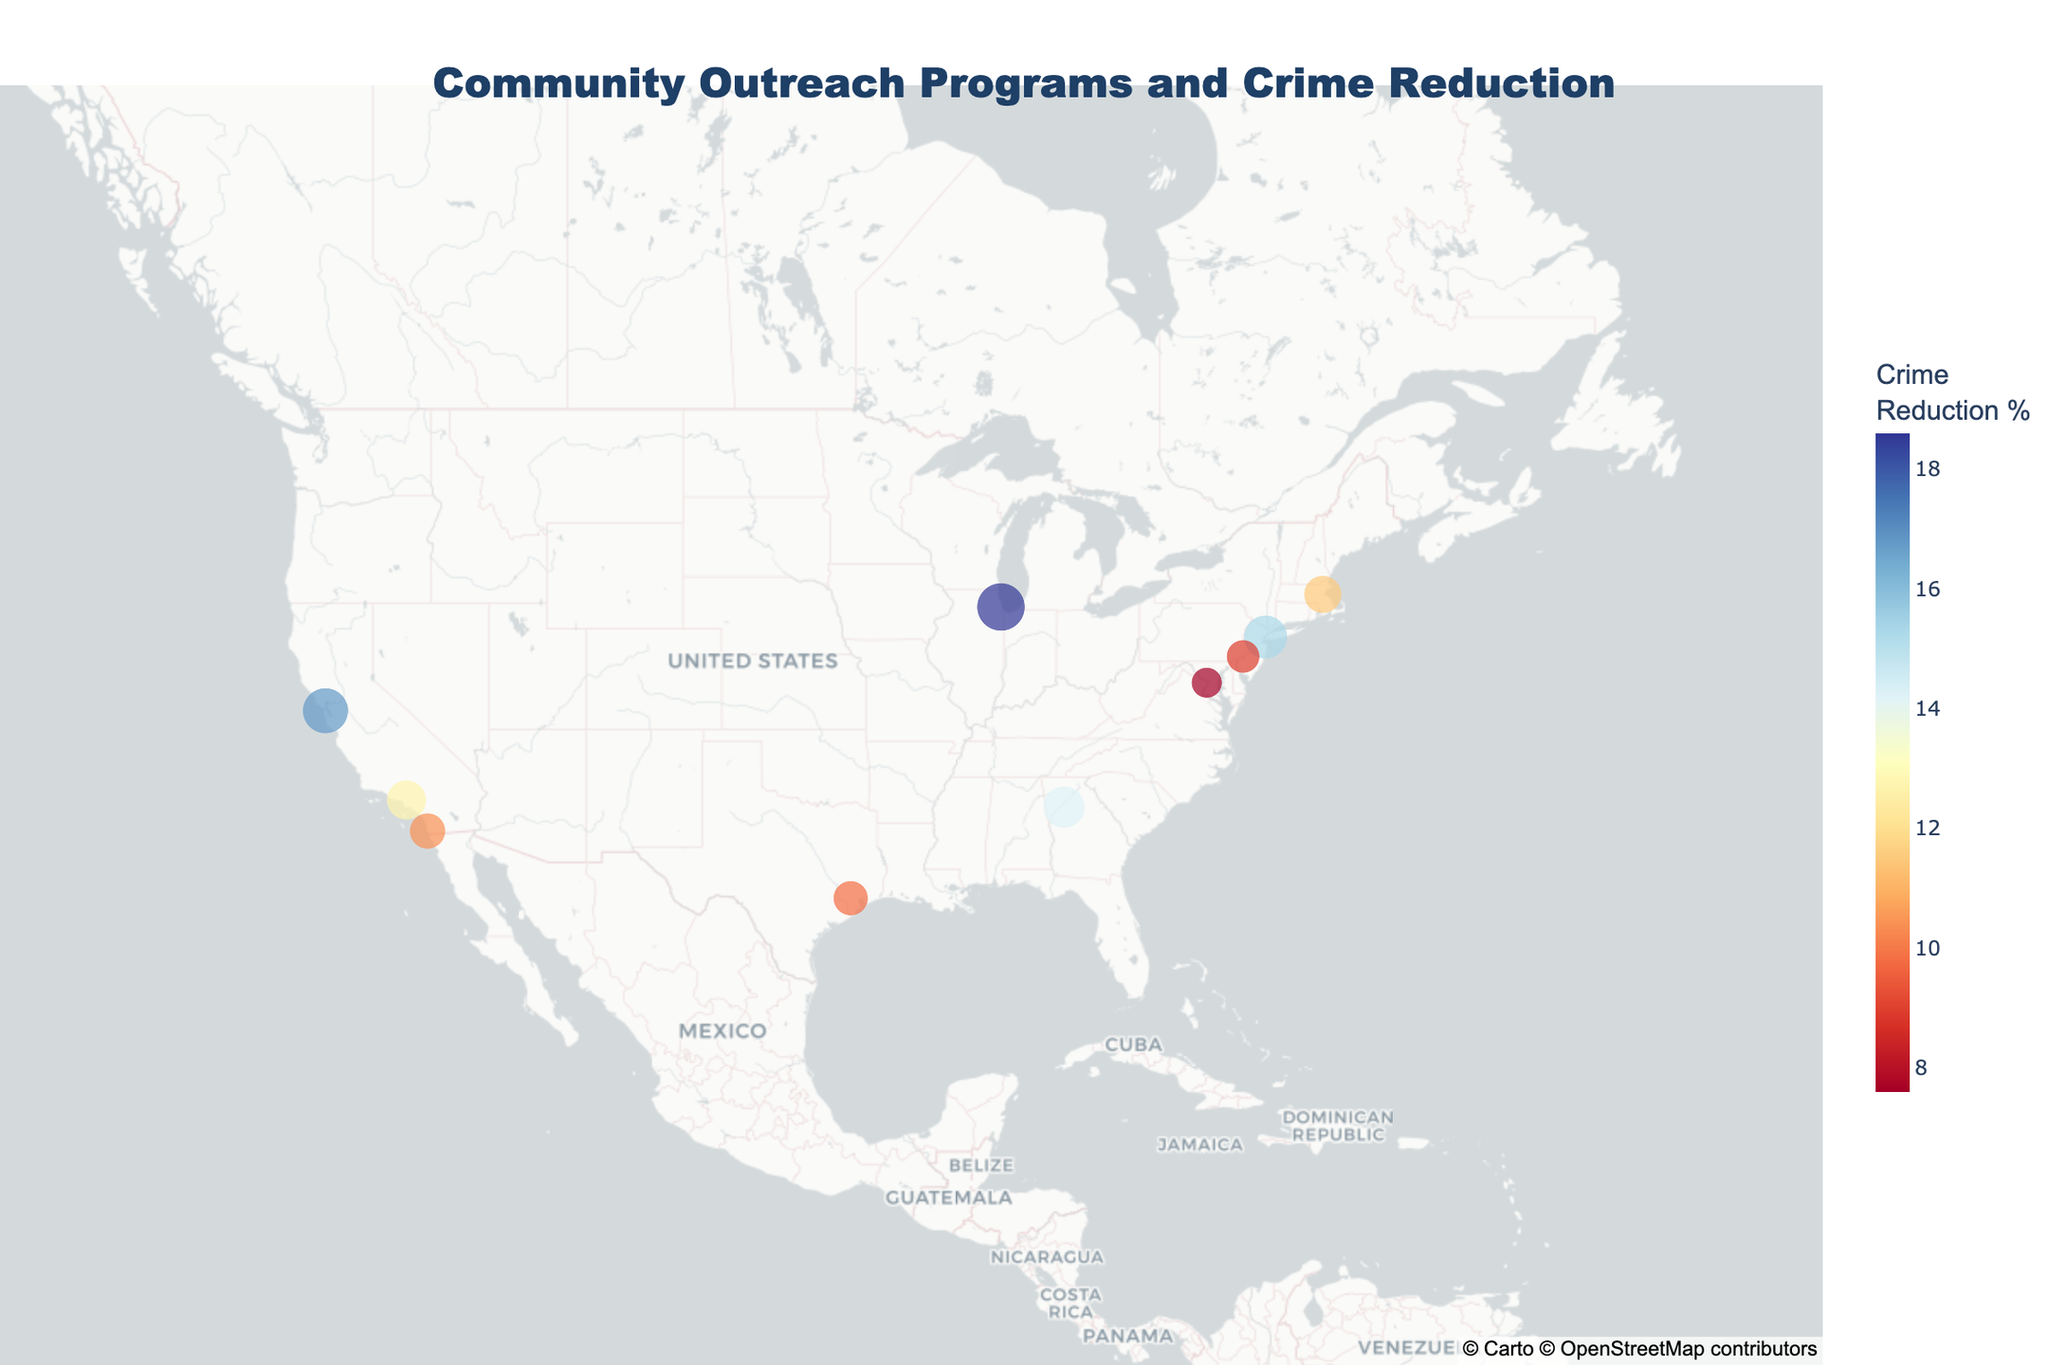Which community outreach program shows the highest crime reduction percentage? The scatter plot shows a number of community outreach programs marked on the map, with their colors and sizes indicating the crime reduction percentages. By examining the largest and most distinctly colored point, we can identify the program with the highest crime reduction percentage, which is the Chicago Neighborhood Watch Alliance.
Answer: Chicago Neighborhood Watch Alliance What is the range of crime reduction percentages among the programs? To find the range, we need to identify the highest and lowest crime reduction percentages displayed by the data points on the map. The highest value is 18.6% (Chicago Neighborhood Watch Alliance) and the lowest is 7.6% (DC Homeless Outreach Team). The range is then calculated as 18.6% - 7.6% = 11%.
Answer: 11% Which program type appears most frequently on the map? The hover data for each data point provides the program type. By examining the frequency of each type, we can determine that the 'Youth Mentoring', 'Job Training', 'Community Policing', 'Ex-Offender Support', 'After-School Activities', 'Conflict Resolution', 'Addiction Recovery', 'Homeless Support', 'Gang Intervention', and 'Police-Community Relations' types are represented. Each program type appears only once.
Answer: Each type appears once Which city has the lowest crime reduction percentage and what is that percentage? To find the city with the lowest crime reduction percentage, look for the smallest and least distinctly colored data point on the map. The city is Washington, D.C. with the DC Homeless Outreach Team, showing a crime reduction percentage of 7.6%.
Answer: Washington, D.C., 7.6% What is the total number of community outreach programs depicted on the map? The number of data points on the map represents the number of community outreach programs. By counting these data points, we find a total of 10 programs.
Answer: 10 What is the average crime reduction percentage across all programs? To find the average, sum the crime reduction percentages of all programs and divide by the total number of programs. The percentages are 15.3, 12.7, 18.6, 9.8, 14.2, 11.5, 8.9, 7.6, 16.8, and 10.4. Sum: 125.8. Average: 125.8 / 10 = 12.58%.
Answer: 12.58% Which two cities have the closest crime reduction percentages, and what are those percentages? To find the closest percentages, compare the values for all pairs of cities. The closest percentages are between Boston Community Mediation Program (11.5%) and San Diego Police-Community Basketball League (10.4%), with a difference of 1.1%.
Answer: Boston (11.5%), San Diego (10.4%) Which city has the highest crime reduction percentage for Youth Mentoring programs, and what is that percentage? Only one city on the map has a Youth Mentoring program, which is Harlem Youth Empowerment Center in New York, with a crime reduction percentage of 15.3%.
Answer: New York, 15.3% What is the color scale used in the plot, and what does it represent? The color scale used in the plot transitions from red to yellow to blue (RdYlBu), representing the range of crime reduction percentages, with different colors indicating different levels of crime reduction.
Answer: Red-Yellow-Blue, crime reduction percentages How is the crime reduction percentage visually represented on the map besides the color scale? Besides the color scale, the crime reduction percentage is also represented by the size of the data points; larger points correspond to higher crime reduction percentages.
Answer: Size of data points 